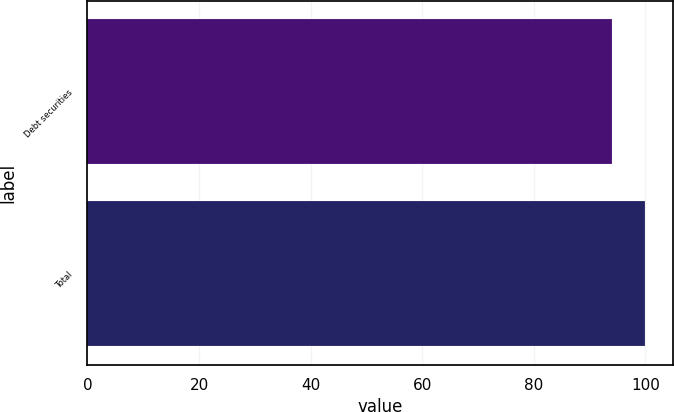Convert chart to OTSL. <chart><loc_0><loc_0><loc_500><loc_500><bar_chart><fcel>Debt securities<fcel>Total<nl><fcel>94<fcel>100<nl></chart> 